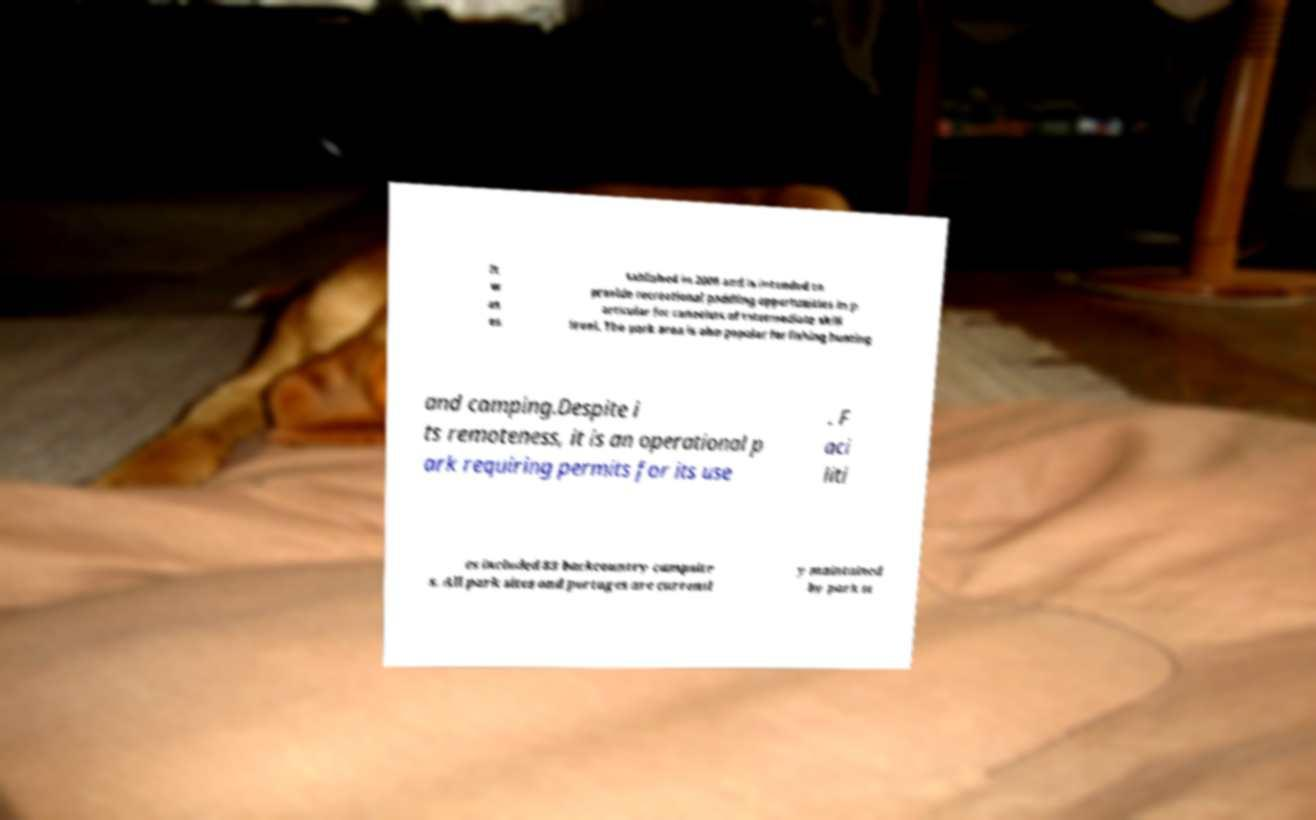Can you read and provide the text displayed in the image?This photo seems to have some interesting text. Can you extract and type it out for me? It w as es tablished in 2006 and is intended to provide recreational paddling opportunities in p articular for canoeists of intermediate skill level. The park area is also popular for fishing hunting and camping.Despite i ts remoteness, it is an operational p ark requiring permits for its use . F aci liti es included 83 backcountry campsite s. All park sites and portages are currentl y maintained by park st 